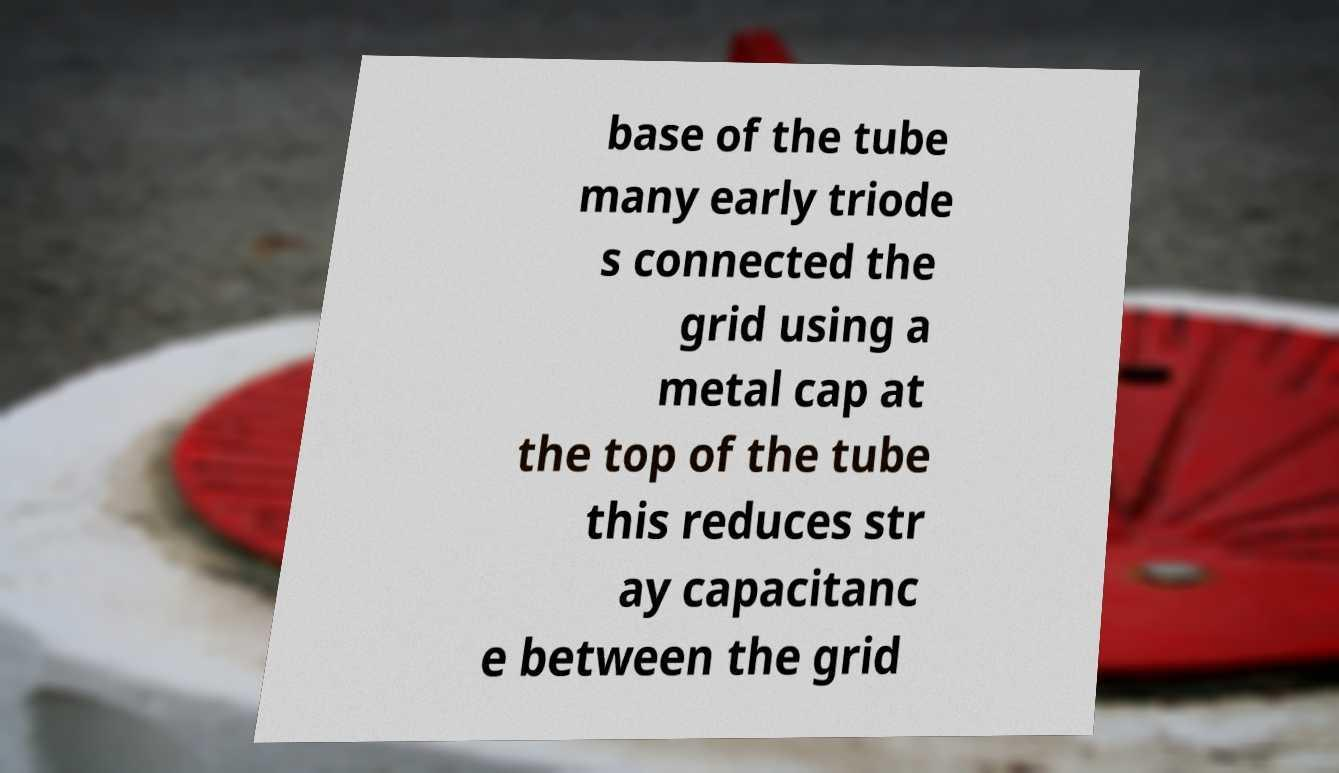I need the written content from this picture converted into text. Can you do that? base of the tube many early triode s connected the grid using a metal cap at the top of the tube this reduces str ay capacitanc e between the grid 